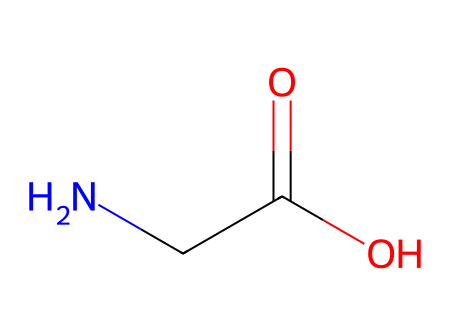What is the central functional group in this chemical? The structure shows a carbonyl group (C=O) and a hydroxyl group (OH) attached to a carbon, indicating that this chemical features a carboxylic acid functional group.
Answer: carboxylic acid How many carbon atoms does this chemical contain? By examining the SMILES representation, we see that there are two carbon atoms present in the structure (one in the carboxyl group and one in the amine).
Answer: two What type of bond connects the nitrogen atom to the carbon atom in this chemical? The bond between nitrogen and the carbon atom, indicated in the structure, is a single covalent bond typically found in amines.
Answer: single bond Does this chemical have any acidic properties? The presence of the carboxylic acid functional group (–COOH) suggests that this chemical can donate a proton (H+) and thus exhibit acidic properties.
Answer: yes What is the overall charge of this chemical at physiological pH? At physiological pH, the carboxylic acid can lose a proton, resulting in a negative charge, while the amine group can be protonated to carry a positive charge, yielding a zwitterionic form.
Answer: zwitterionic 